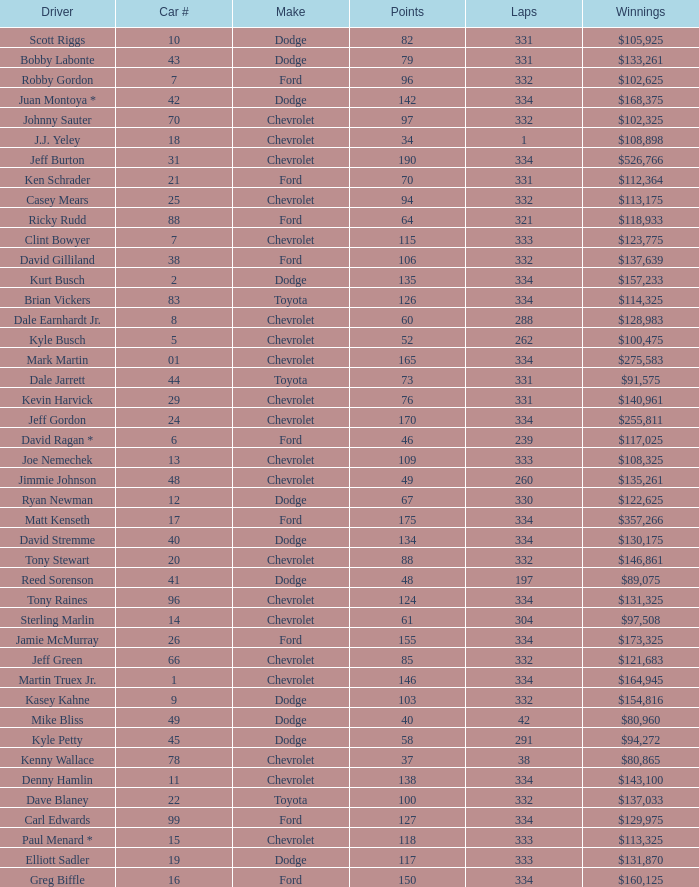How many total laps did the Chevrolet that won $97,508 make? 1.0. 